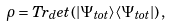Convert formula to latex. <formula><loc_0><loc_0><loc_500><loc_500>\rho = T r _ { d } e t \left ( | \Psi _ { t o t } \rangle \langle \Psi _ { t o t } | \right ) ,</formula> 